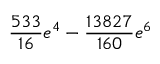Convert formula to latex. <formula><loc_0><loc_0><loc_500><loc_500>\frac { 5 3 3 } { 1 6 } e ^ { 4 } - \frac { 1 3 8 2 7 } { 1 6 0 } e ^ { 6 }</formula> 